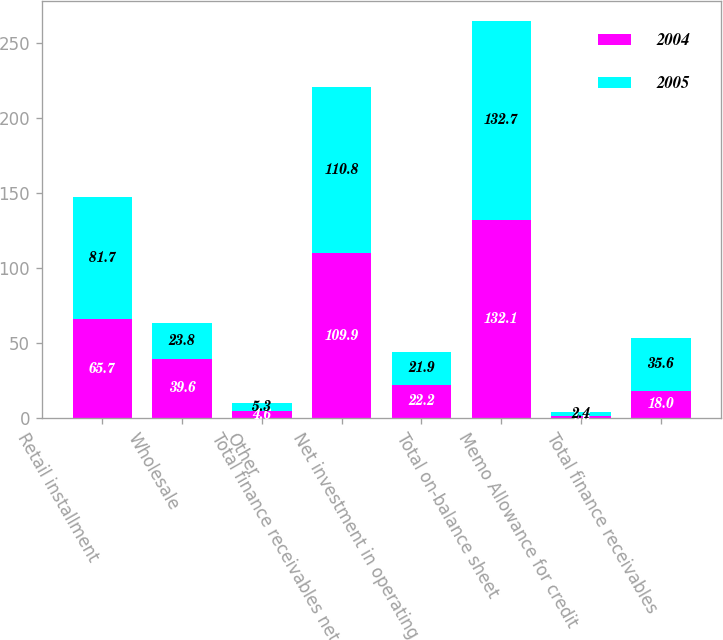Convert chart to OTSL. <chart><loc_0><loc_0><loc_500><loc_500><stacked_bar_chart><ecel><fcel>Retail installment<fcel>Wholesale<fcel>Other<fcel>Total finance receivables net<fcel>Net investment in operating<fcel>Total on-balance sheet<fcel>Memo Allowance for credit<fcel>Total finance receivables<nl><fcel>2004<fcel>65.7<fcel>39.6<fcel>4.6<fcel>109.9<fcel>22.2<fcel>132.1<fcel>1.6<fcel>18<nl><fcel>2005<fcel>81.7<fcel>23.8<fcel>5.3<fcel>110.8<fcel>21.9<fcel>132.7<fcel>2.4<fcel>35.6<nl></chart> 